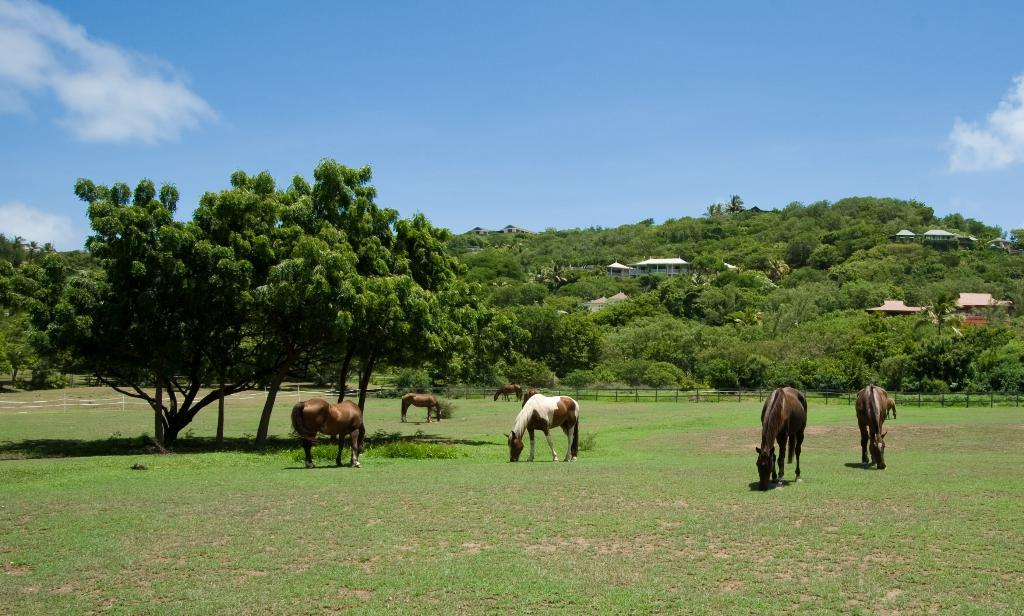What animals can be seen on the grass in the image? There are many horses on the grass in the image. What can be seen on the left side of the image? There are trees on the left side of the image. What type of vegetation is visible in the background of the image? There is grass visible in the background of the image. What architectural feature is present in the background of the image? There is fencing in the background of the image. What geographical feature is visible in the background of the image? There is a hill in the background of the image. What type of structures can be seen in the background of the image? There are houses in the background of the image. What part of the natural environment is visible in the background of the image? The sky is visible in the background of the image. What weather condition can be observed in the sky? There are clouds in the sky. Can you see a squirrel washing its ear in the image? There is no squirrel or any washing activity visible in the image. 